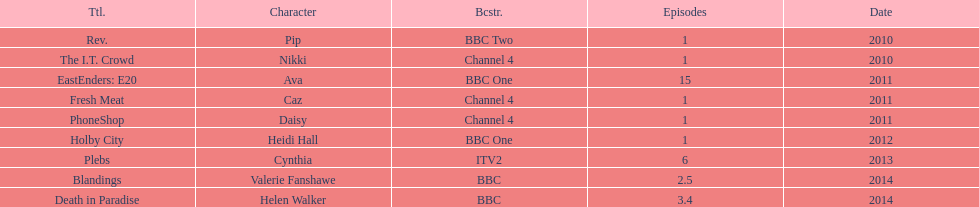Which broadcaster hosted 3 titles but they had only 1 episode? Channel 4. 